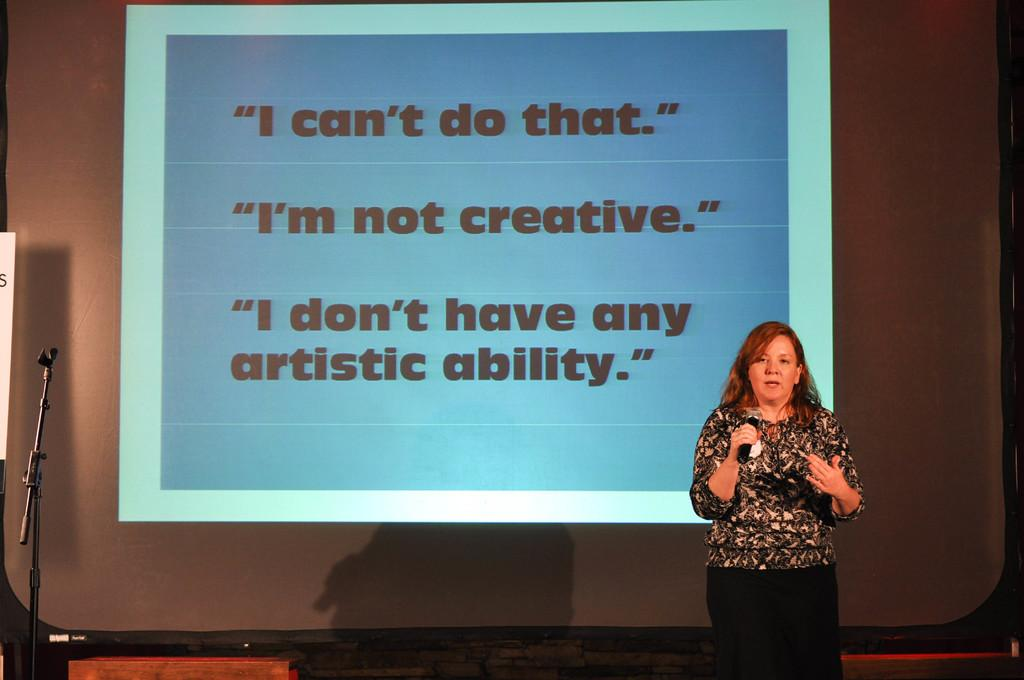What is the main subject of the image? There is a woman standing in the image. What is the woman wearing? The woman is wearing clothes. What object is the woman holding in her hand? The woman is holding a microphone in her hand. What can be seen in the background of the image? There is a stand and a projected screen in the image. What type of berry can be seen growing on the stem in the image? There is no berry or stem present in the image. How does the fog affect the visibility of the projected screen in the image? There is no fog present in the image, so its effect on the visibility of the projected screen cannot be determined. 